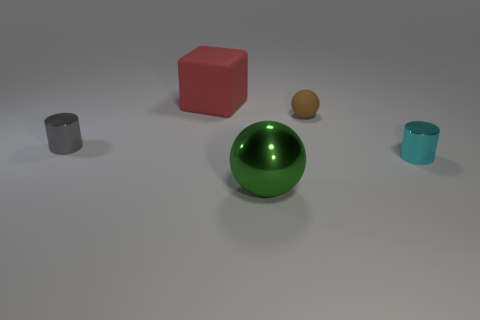Add 3 tiny cyan cylinders. How many objects exist? 8 Subtract all cylinders. How many objects are left? 3 Subtract all small balls. Subtract all cyan objects. How many objects are left? 3 Add 4 tiny gray cylinders. How many tiny gray cylinders are left? 5 Add 4 big gray matte cubes. How many big gray matte cubes exist? 4 Subtract 1 gray cylinders. How many objects are left? 4 